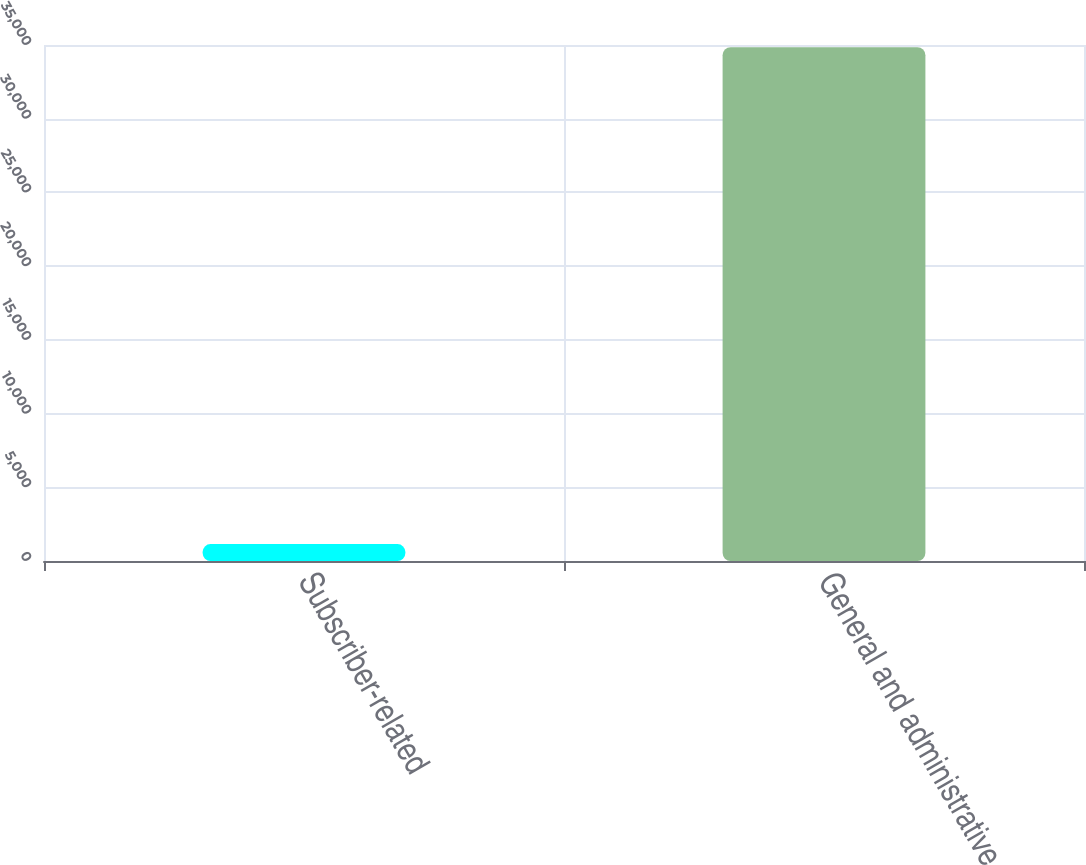<chart> <loc_0><loc_0><loc_500><loc_500><bar_chart><fcel>Subscriber-related<fcel>General and administrative<nl><fcel>1150<fcel>34849<nl></chart> 